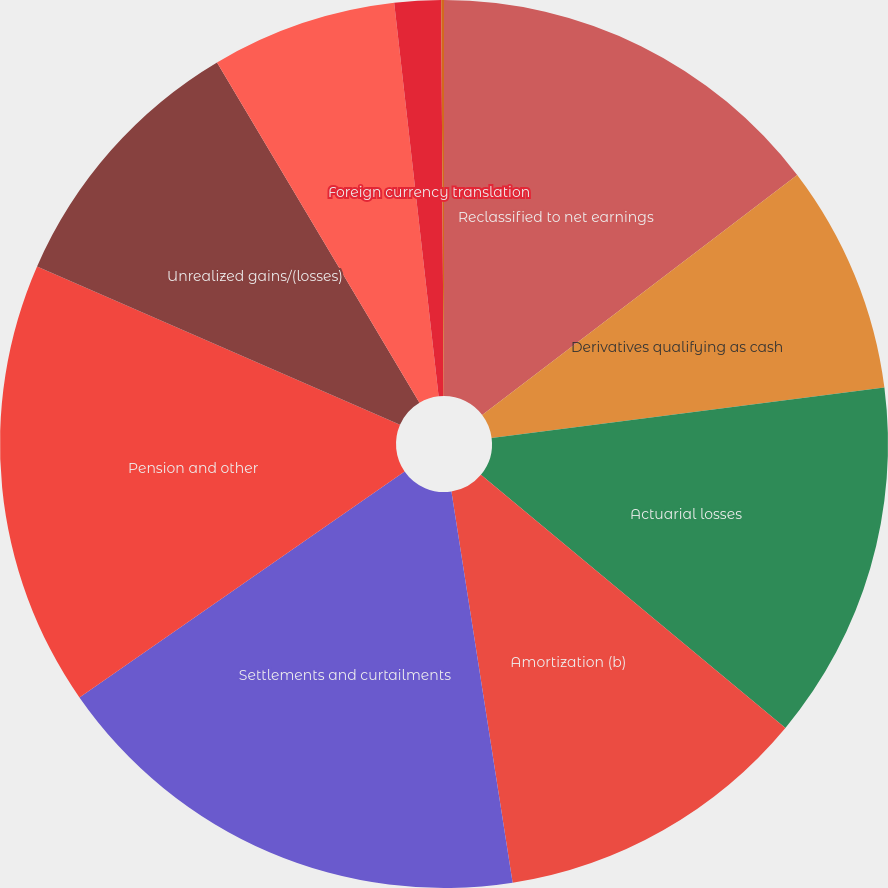Convert chart to OTSL. <chart><loc_0><loc_0><loc_500><loc_500><pie_chart><fcel>Reclassified to net earnings<fcel>Derivatives qualifying as cash<fcel>Actuarial losses<fcel>Amortization (b)<fcel>Settlements and curtailments<fcel>Pension and other<fcel>Unrealized gains/(losses)<fcel>Available-for-sale securities<fcel>Foreign currency translation<fcel>Total Other Comprehensive<nl><fcel>14.64%<fcel>8.33%<fcel>13.07%<fcel>11.49%<fcel>17.8%<fcel>16.22%<fcel>9.91%<fcel>6.75%<fcel>1.69%<fcel>0.1%<nl></chart> 